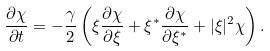<formula> <loc_0><loc_0><loc_500><loc_500>\frac { \partial \chi } { \partial t } = - \frac { \gamma } { 2 } \left ( \xi \frac { \partial \chi } { \partial \xi } + \xi ^ { \ast } \frac { \partial \chi } { \partial \xi ^ { \ast } } + | \xi | ^ { 2 } \chi \right ) .</formula> 